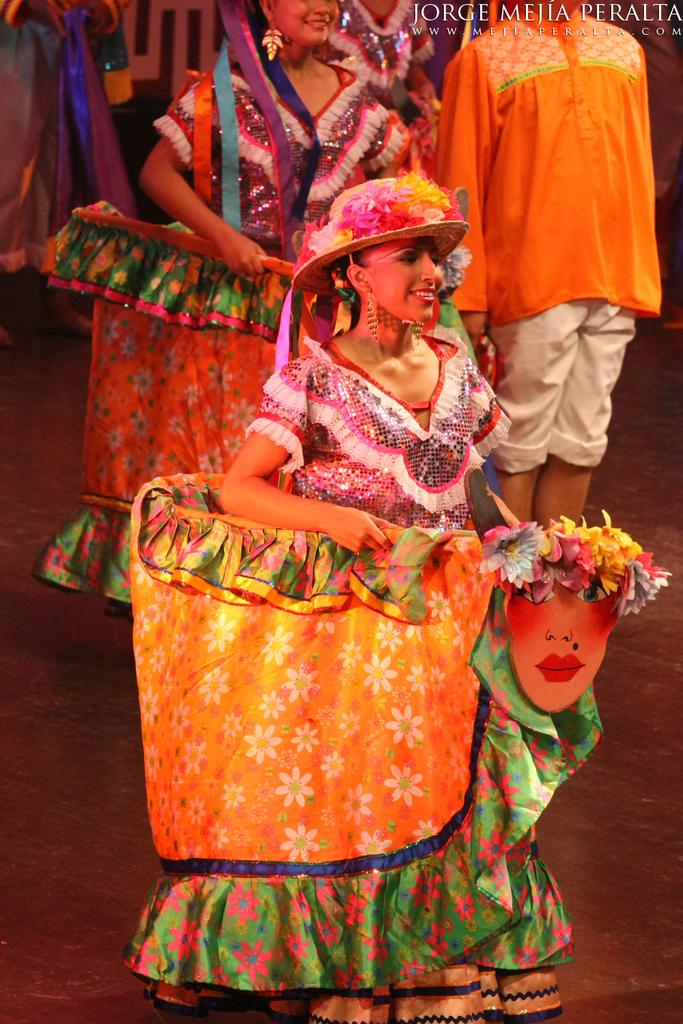What are the people in the image wearing? There are many people wearing costumes in the image. Can you describe the lady in the front? The lady in the front is wearing a cap with flowers. Is there any text or symbol visible in the image? Yes, there is a watermark in the right top corner of the image. Can you tell me how many umbrellas are being carried by the people in the image? There is no mention of umbrellas in the image, so it is not possible to determine how many are being carried. 